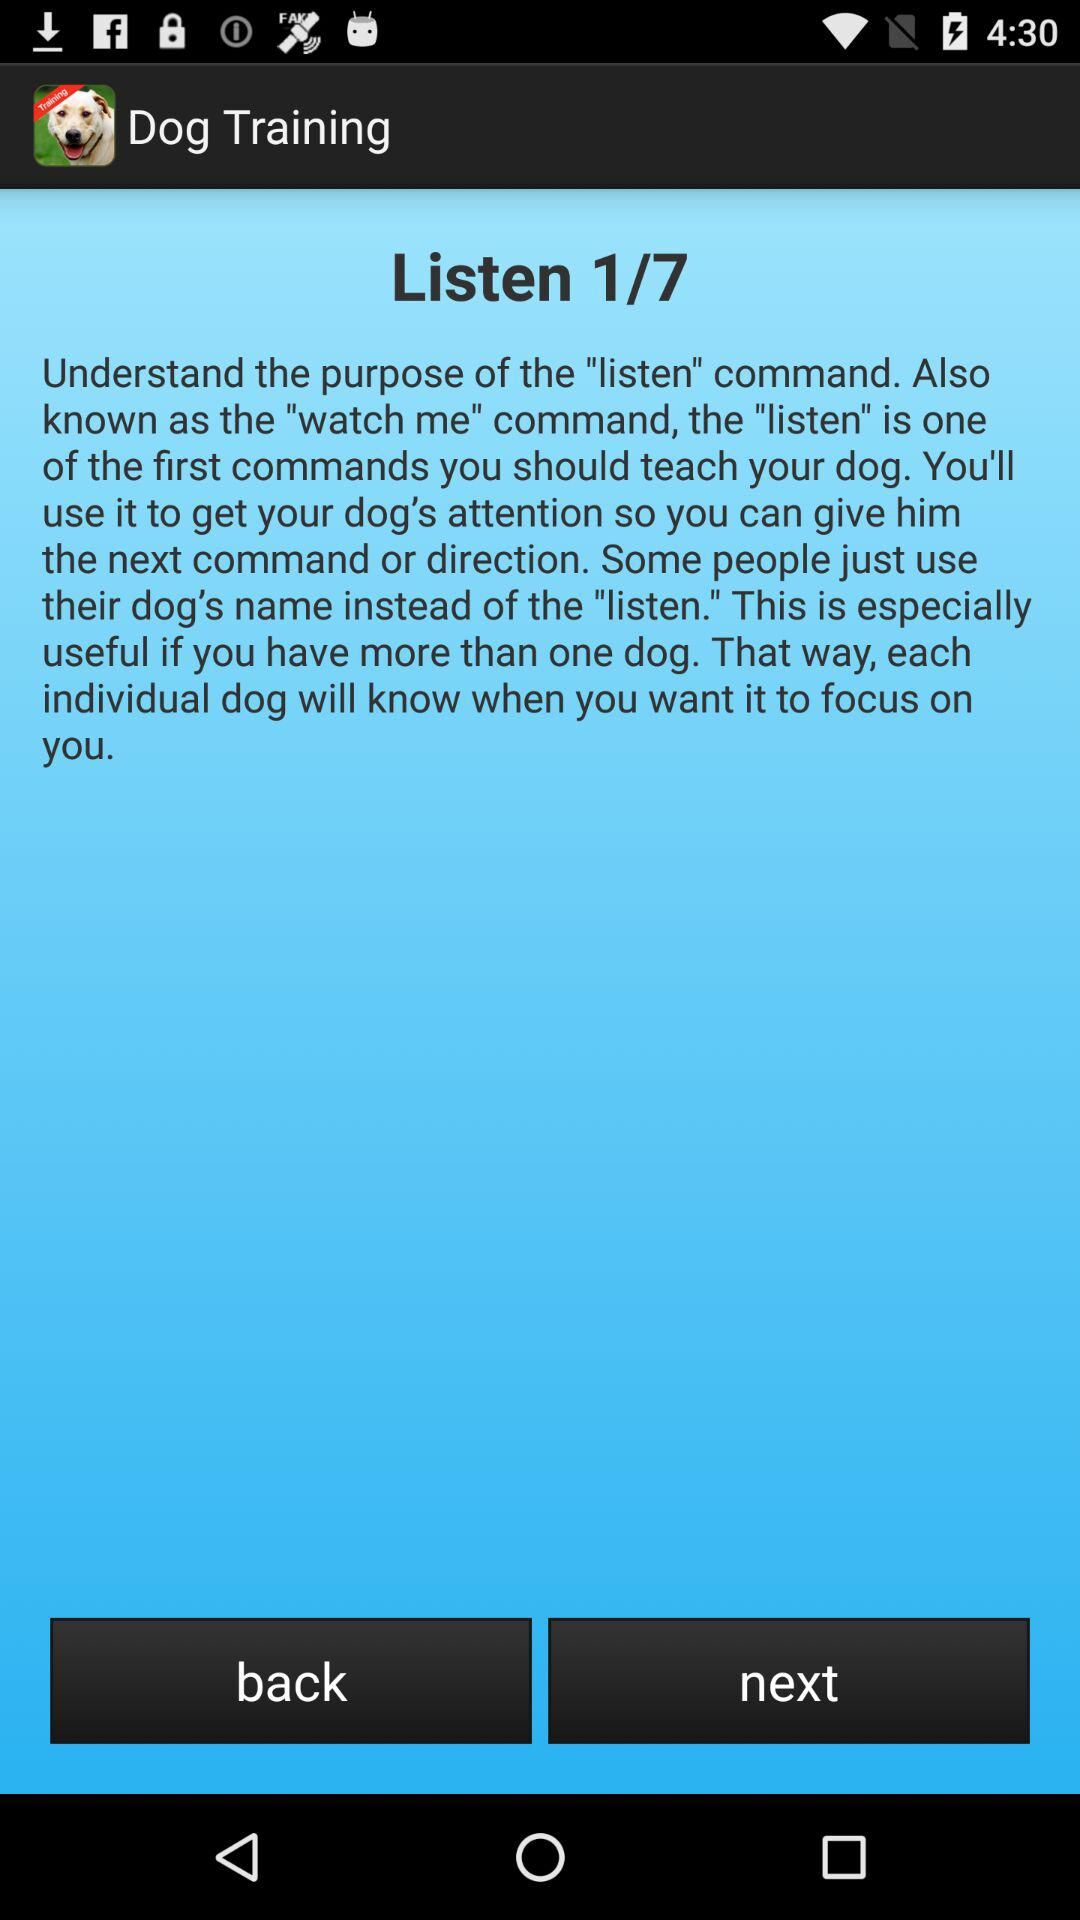What's the total number of commands? The total number of commands is 7. 